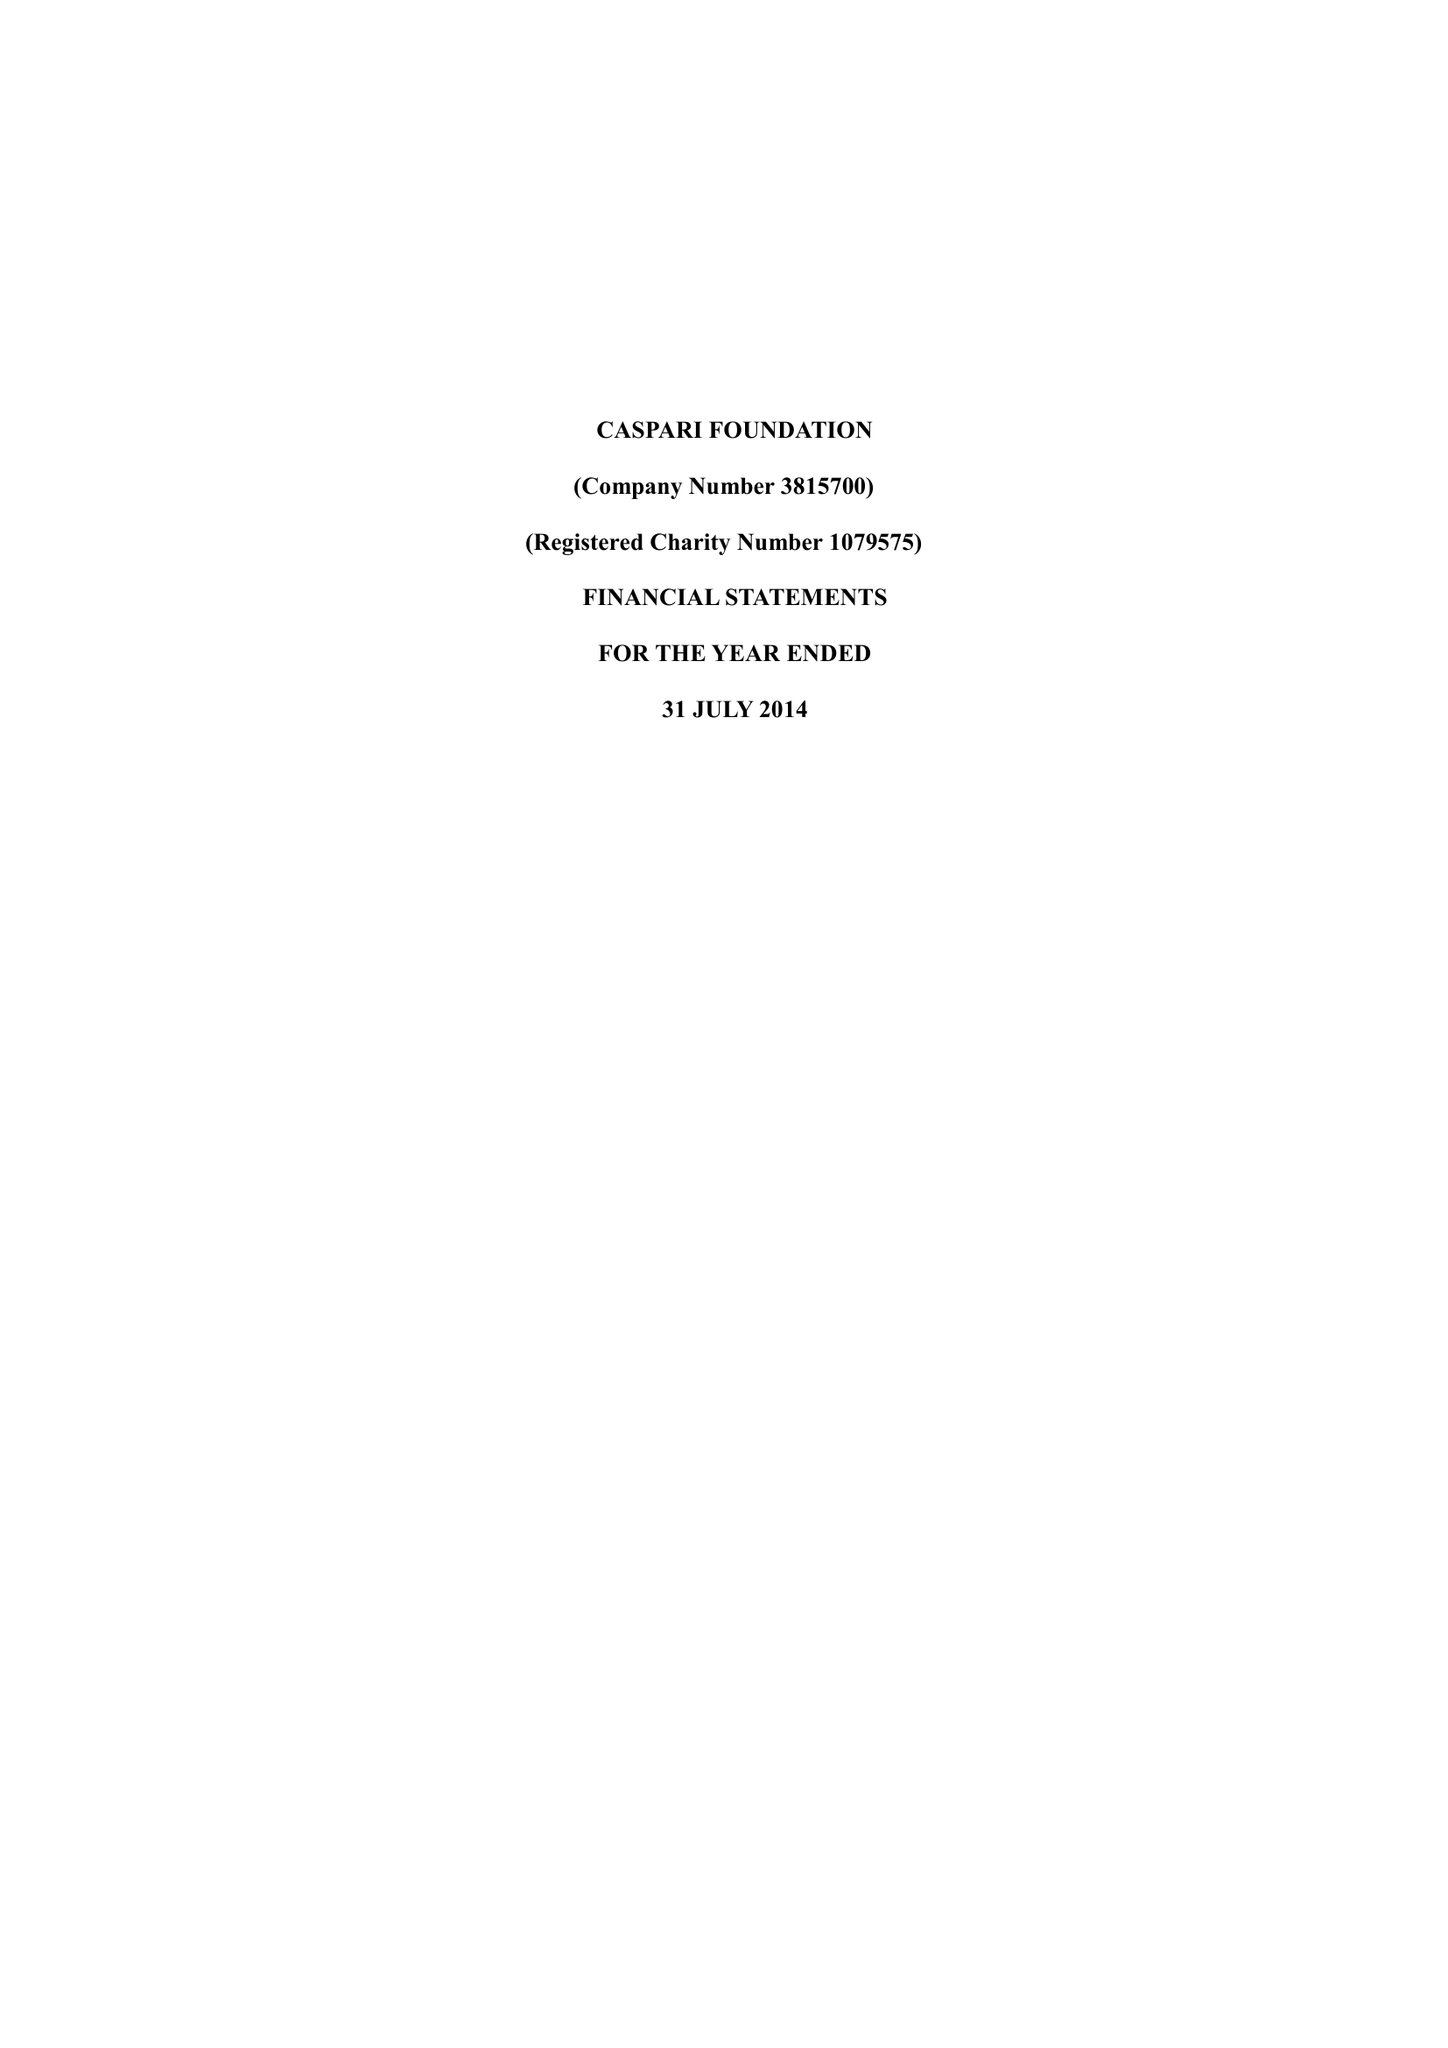What is the value for the spending_annually_in_british_pounds?
Answer the question using a single word or phrase. 204573.00 